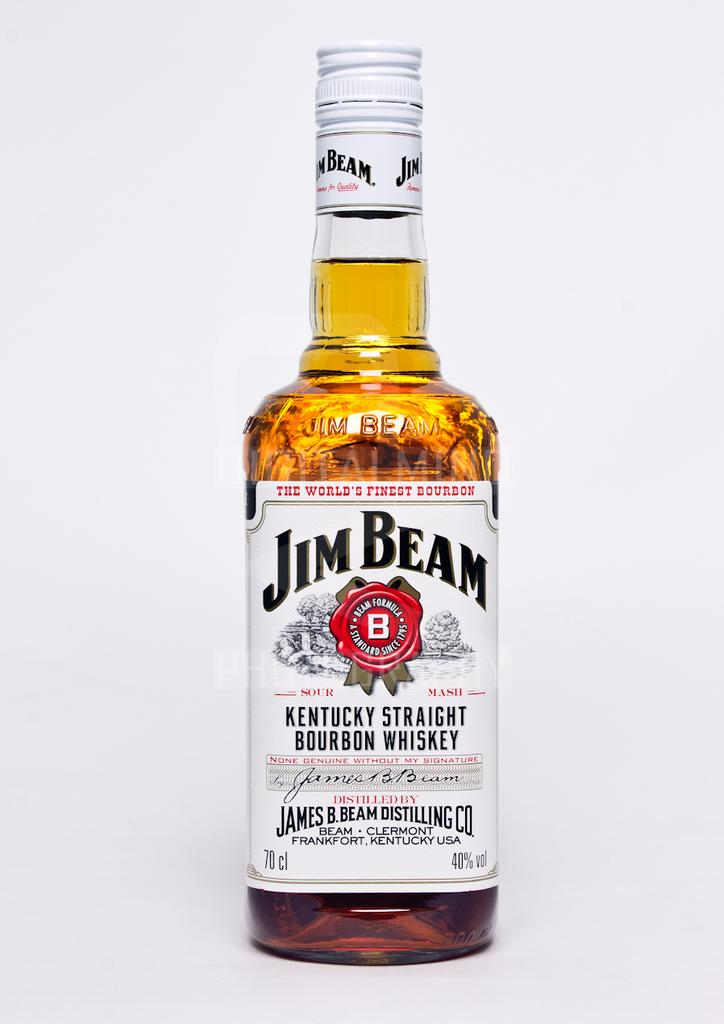<image>
Relay a brief, clear account of the picture shown. A bottle of Jim Beam bourbon whisky against a pure white background. 